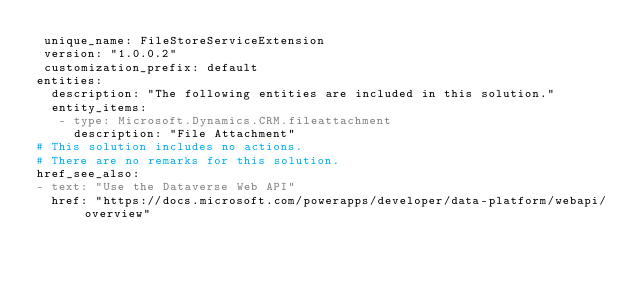Convert code to text. <code><loc_0><loc_0><loc_500><loc_500><_YAML_> unique_name: FileStoreServiceExtension
 version: "1.0.0.2"
 customization_prefix: default
entities:
  description: "The following entities are included in this solution."
  entity_items:
   - type: Microsoft.Dynamics.CRM.fileattachment
     description: "File Attachment"
# This solution includes no actions.
# There are no remarks for this solution.
href_see_also:
- text: "Use the Dataverse Web API"
  href: "https://docs.microsoft.com/powerapps/developer/data-platform/webapi/overview"</code> 